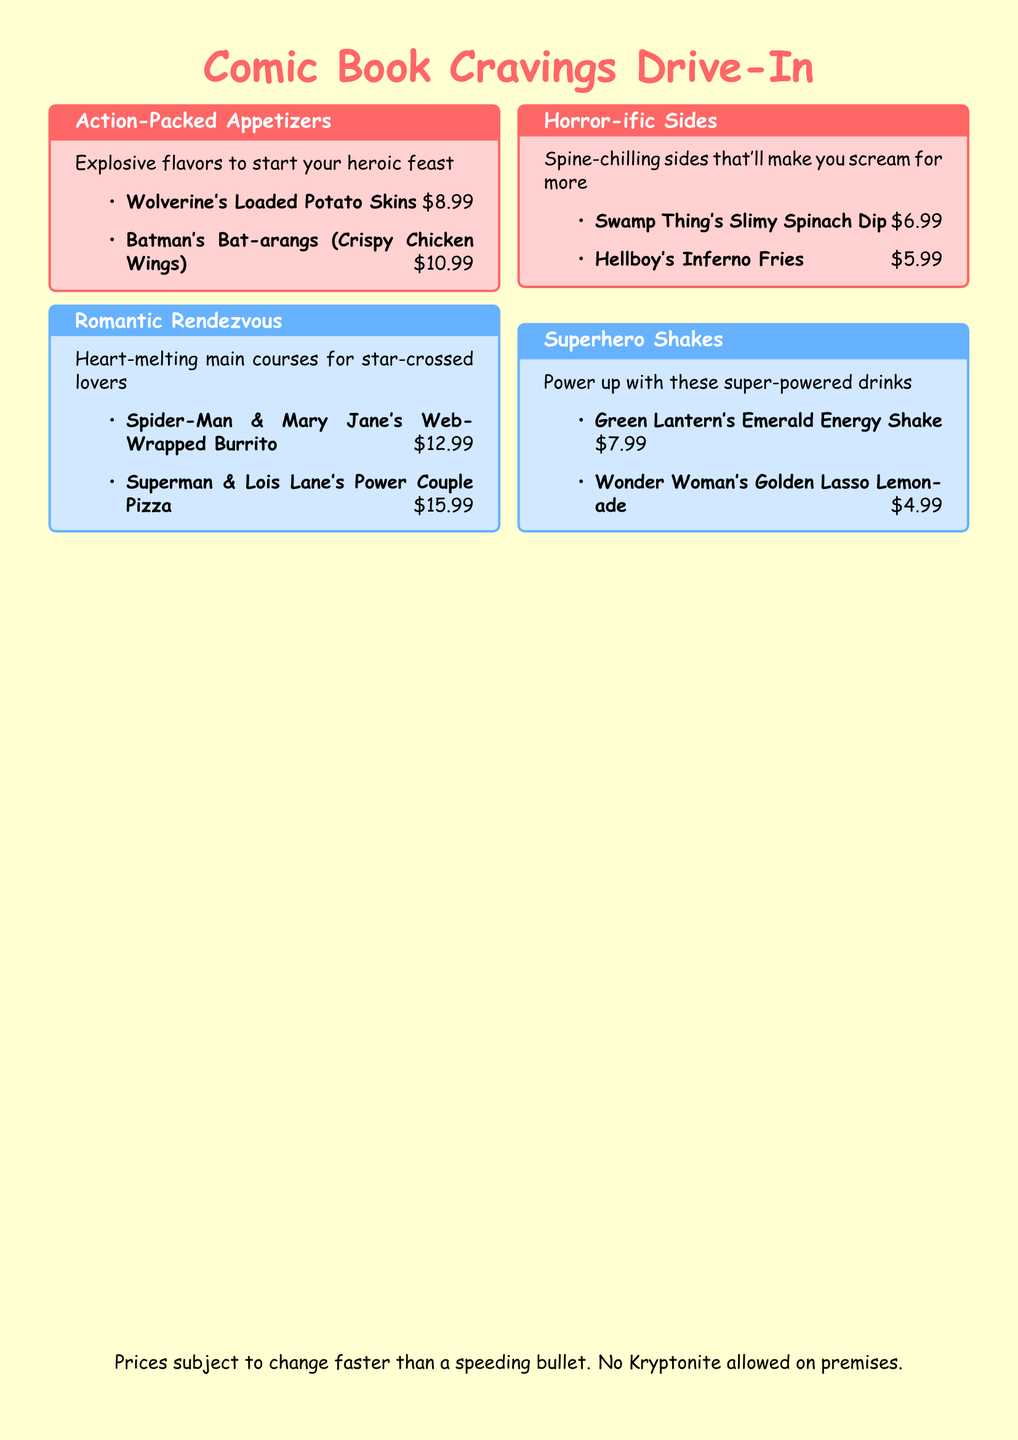What are the names of the appetizers? The appetizer names listed in the document are Wolverine's Loaded Potato Skins and Batman's Bat-arangs (Crispy Chicken Wings).
Answer: Wolverine's Loaded Potato Skins, Batman's Bat-arangs (Crispy Chicken Wings) What is the price of Superman & Lois Lane's Power Couple Pizza? The price for Superman & Lois Lane's Power Couple Pizza is stated in the document.
Answer: $15.99 How many sides are offered in the menu? The document includes two sides under the Horror-ific Sides section.
Answer: 2 What type of drink is Wonder Woman's Golden Lasso Lemonade? The drink is categorized under Superhero Shakes.
Answer: Superhero Shake Which appetizer is priced lower than $7? The document lists Hellboy's Inferno Fries as costing $5.99, which is lower than $7.
Answer: Hellboy's Inferno Fries What genre is represented with the lowest-priced item? The Horror-ific Sides category contains the lowest-priced item at $5.99.
Answer: Horror Which two characters are featured in the burrito dish? The dish is named after Spider-Man and Mary Jane.
Answer: Spider-Man & Mary Jane What color theme is used for the Horror-ific Sides section? The Horror-ific Sides section uses a comic red background color.
Answer: Comic Red What message is included at the bottom of the menu? The message included at the bottom of the menu warns against bringing Kryptonite.
Answer: No Kryptonite allowed on premises 